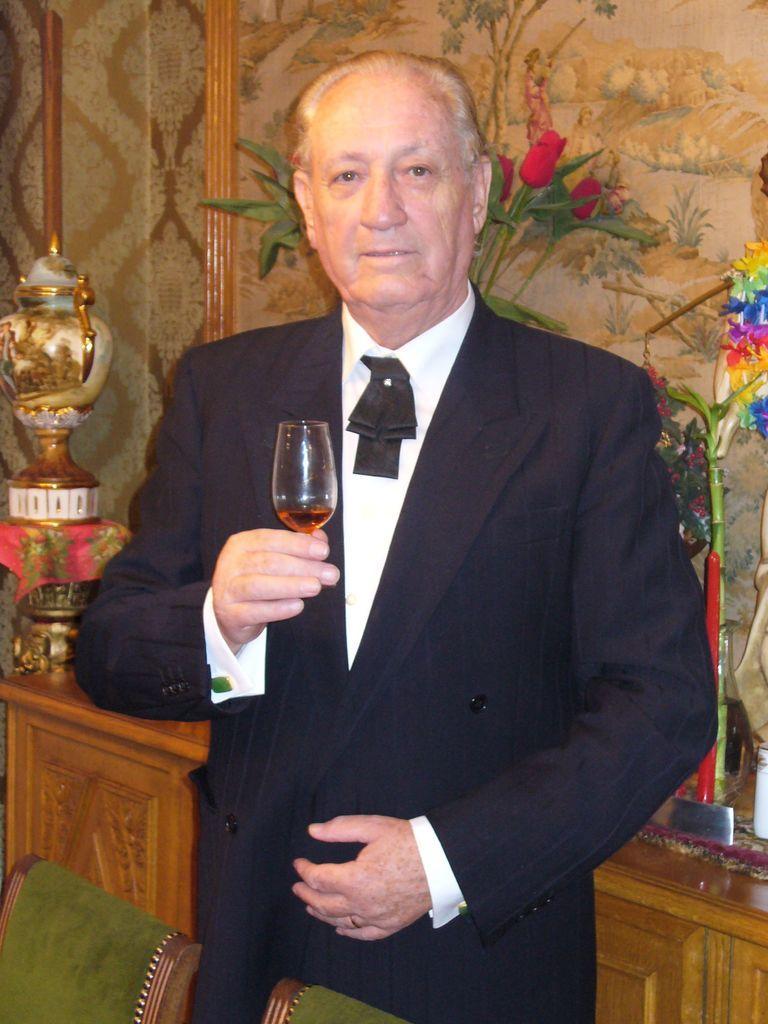Describe this image in one or two sentences. A man is holding wine glass in his stand in front of him there are two chairs. Behind him there are frames on the wall and cupboards. 